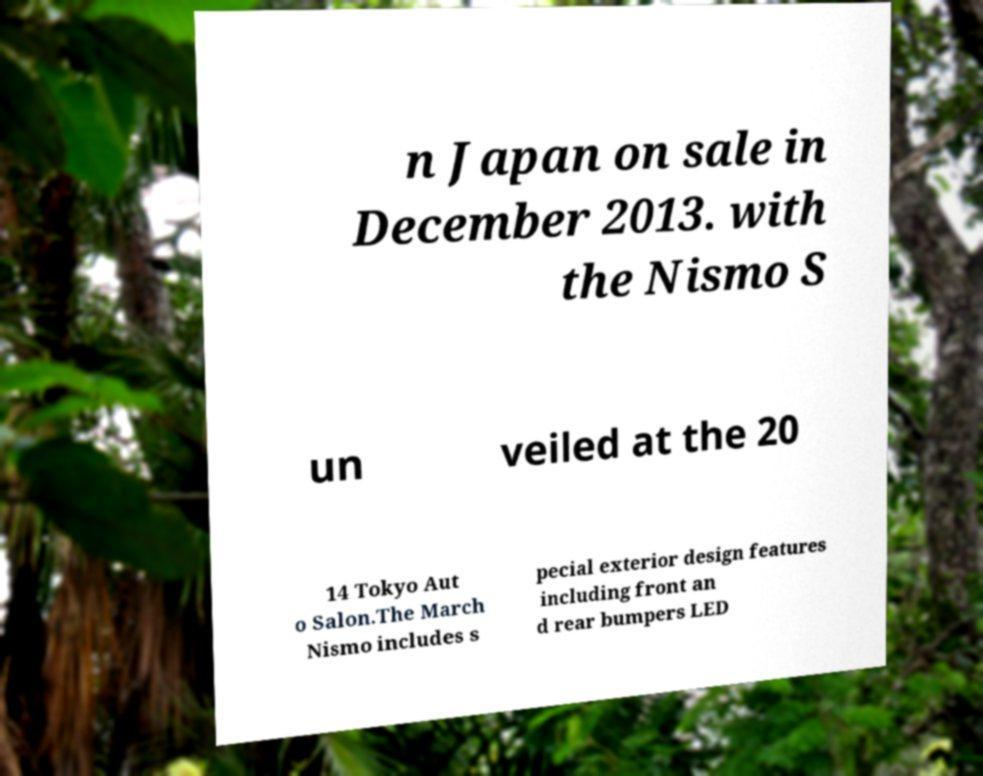Could you extract and type out the text from this image? n Japan on sale in December 2013. with the Nismo S un veiled at the 20 14 Tokyo Aut o Salon.The March Nismo includes s pecial exterior design features including front an d rear bumpers LED 